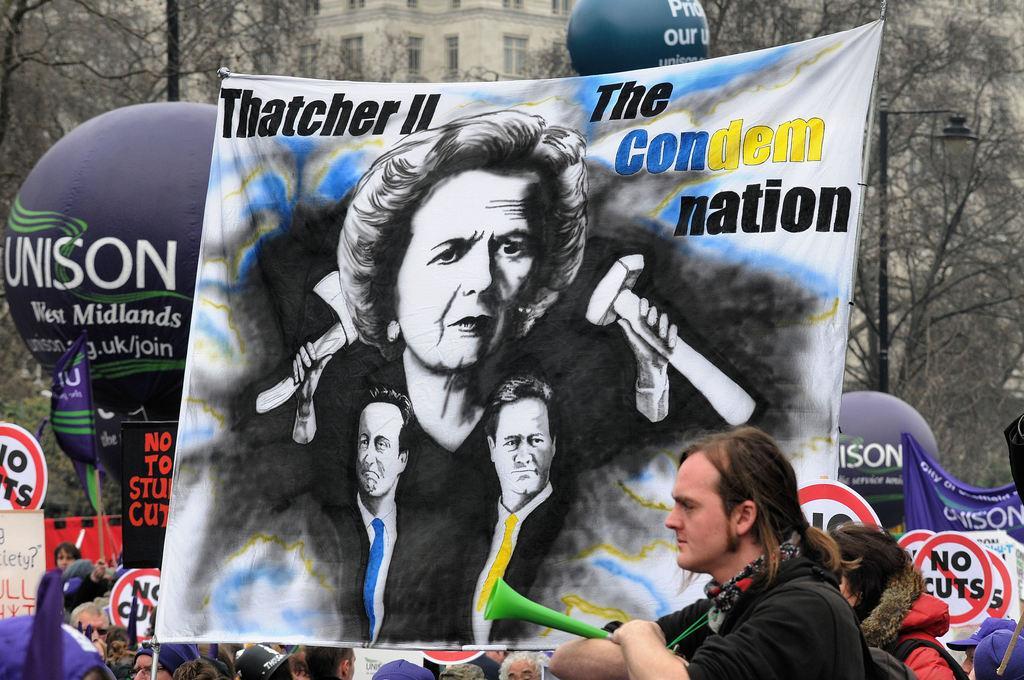Please provide a concise description of this image. This is an outside view. At the bottom of this image I can see a crowd of people and there are some boards on which I can see the text. In the middle of the image there is a banner on which I can see few images of persons, tools and the text. In the background there are balloons and trees. At the top of the image there is a building. 